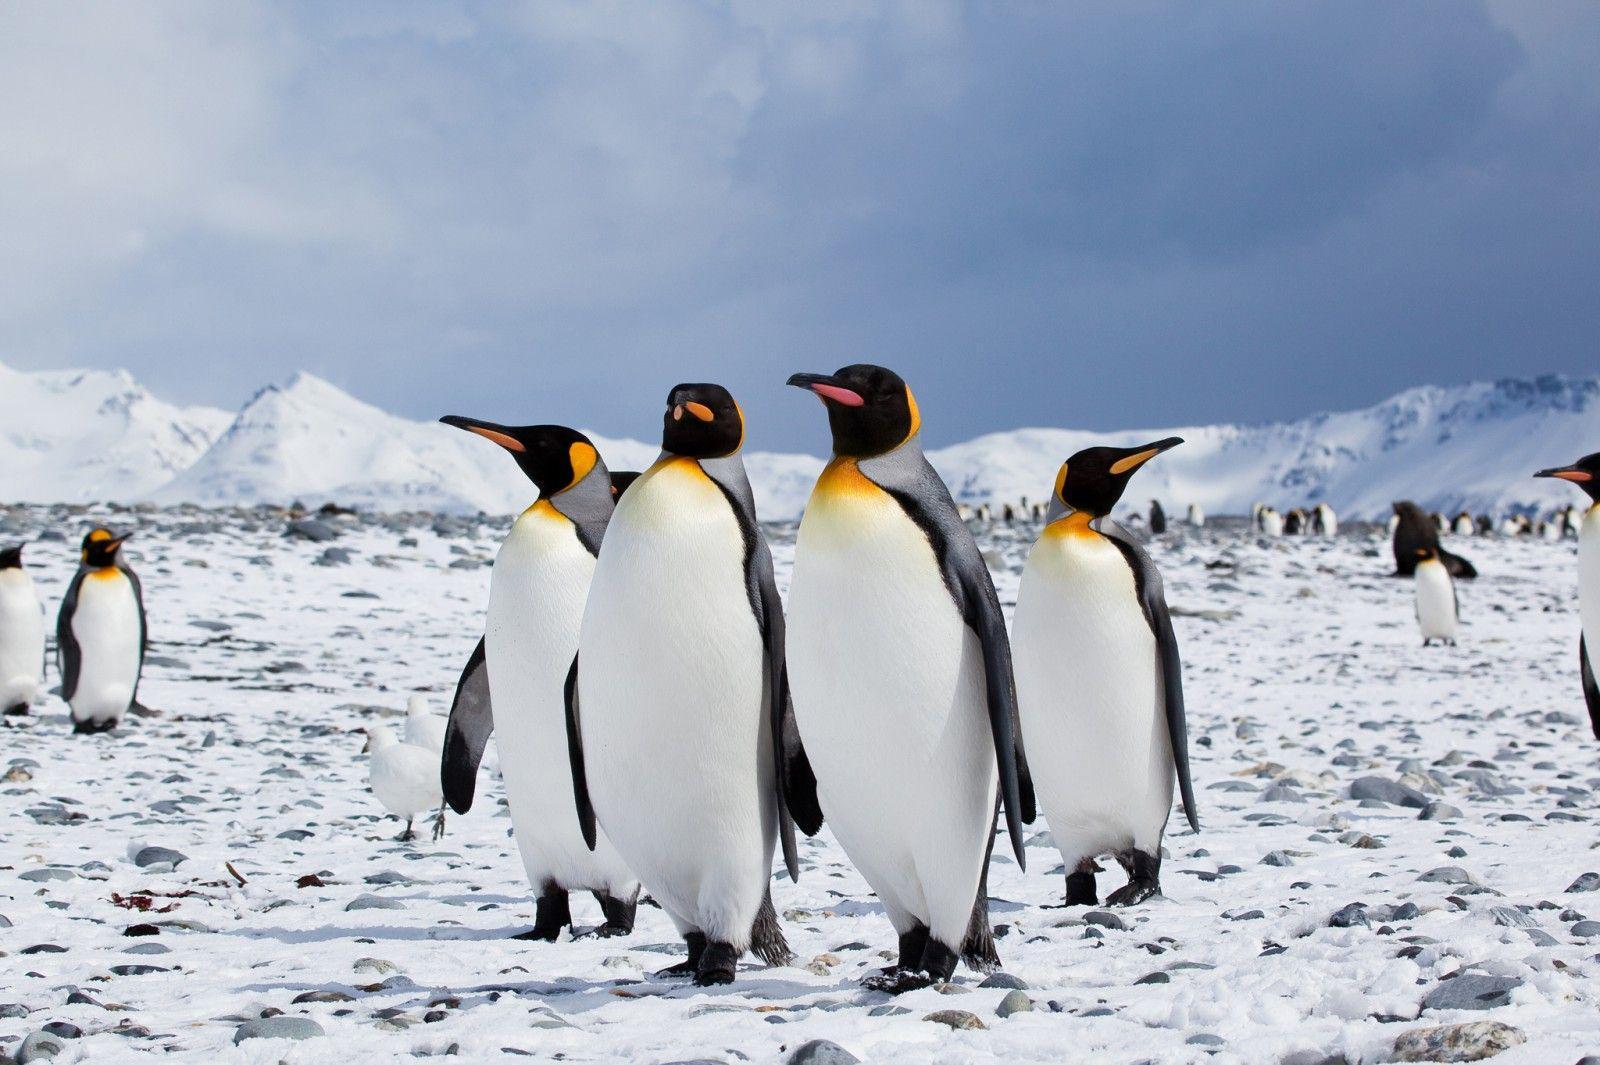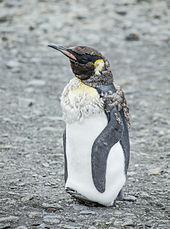The first image is the image on the left, the second image is the image on the right. Considering the images on both sides, is "In one image, exactly four penguins are standing together." valid? Answer yes or no. Yes. The first image is the image on the left, the second image is the image on the right. For the images shown, is this caption "the penguin in the image on the right is looking down" true? Answer yes or no. No. 